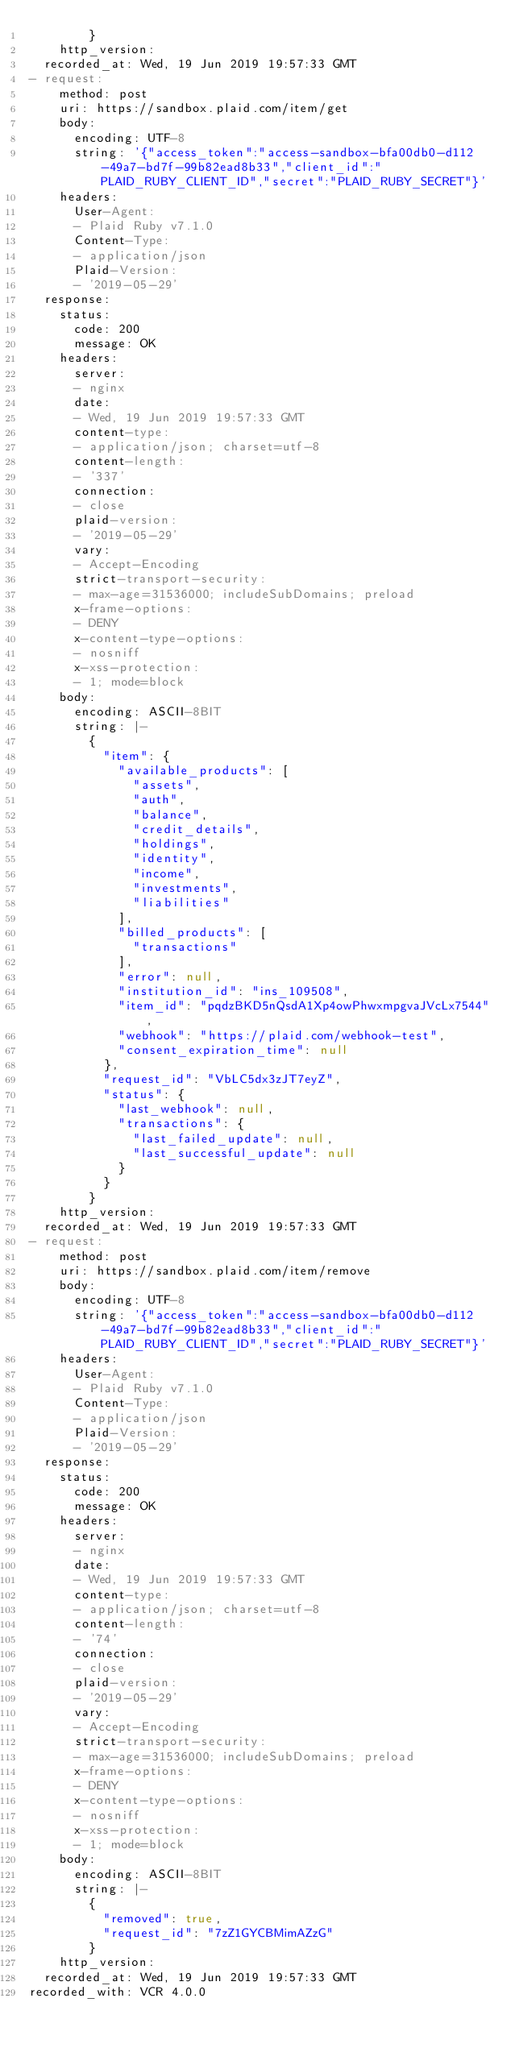Convert code to text. <code><loc_0><loc_0><loc_500><loc_500><_YAML_>        }
    http_version: 
  recorded_at: Wed, 19 Jun 2019 19:57:33 GMT
- request:
    method: post
    uri: https://sandbox.plaid.com/item/get
    body:
      encoding: UTF-8
      string: '{"access_token":"access-sandbox-bfa00db0-d112-49a7-bd7f-99b82ead8b33","client_id":"PLAID_RUBY_CLIENT_ID","secret":"PLAID_RUBY_SECRET"}'
    headers:
      User-Agent:
      - Plaid Ruby v7.1.0
      Content-Type:
      - application/json
      Plaid-Version:
      - '2019-05-29'
  response:
    status:
      code: 200
      message: OK
    headers:
      server:
      - nginx
      date:
      - Wed, 19 Jun 2019 19:57:33 GMT
      content-type:
      - application/json; charset=utf-8
      content-length:
      - '337'
      connection:
      - close
      plaid-version:
      - '2019-05-29'
      vary:
      - Accept-Encoding
      strict-transport-security:
      - max-age=31536000; includeSubDomains; preload
      x-frame-options:
      - DENY
      x-content-type-options:
      - nosniff
      x-xss-protection:
      - 1; mode=block
    body:
      encoding: ASCII-8BIT
      string: |-
        {
          "item": {
            "available_products": [
              "assets",
              "auth",
              "balance",
              "credit_details",
              "holdings",
              "identity",
              "income",
              "investments",
              "liabilities"
            ],
            "billed_products": [
              "transactions"
            ],
            "error": null,
            "institution_id": "ins_109508",
            "item_id": "pqdzBKD5nQsdA1Xp4owPhwxmpgvaJVcLx7544",
            "webhook": "https://plaid.com/webhook-test",
            "consent_expiration_time": null
          },
          "request_id": "VbLC5dx3zJT7eyZ",
          "status": {
            "last_webhook": null,
            "transactions": {
              "last_failed_update": null,
              "last_successful_update": null
            }
          }
        }
    http_version: 
  recorded_at: Wed, 19 Jun 2019 19:57:33 GMT
- request:
    method: post
    uri: https://sandbox.plaid.com/item/remove
    body:
      encoding: UTF-8
      string: '{"access_token":"access-sandbox-bfa00db0-d112-49a7-bd7f-99b82ead8b33","client_id":"PLAID_RUBY_CLIENT_ID","secret":"PLAID_RUBY_SECRET"}'
    headers:
      User-Agent:
      - Plaid Ruby v7.1.0
      Content-Type:
      - application/json
      Plaid-Version:
      - '2019-05-29'
  response:
    status:
      code: 200
      message: OK
    headers:
      server:
      - nginx
      date:
      - Wed, 19 Jun 2019 19:57:33 GMT
      content-type:
      - application/json; charset=utf-8
      content-length:
      - '74'
      connection:
      - close
      plaid-version:
      - '2019-05-29'
      vary:
      - Accept-Encoding
      strict-transport-security:
      - max-age=31536000; includeSubDomains; preload
      x-frame-options:
      - DENY
      x-content-type-options:
      - nosniff
      x-xss-protection:
      - 1; mode=block
    body:
      encoding: ASCII-8BIT
      string: |-
        {
          "removed": true,
          "request_id": "7zZ1GYCBMimAZzG"
        }
    http_version: 
  recorded_at: Wed, 19 Jun 2019 19:57:33 GMT
recorded_with: VCR 4.0.0
</code> 